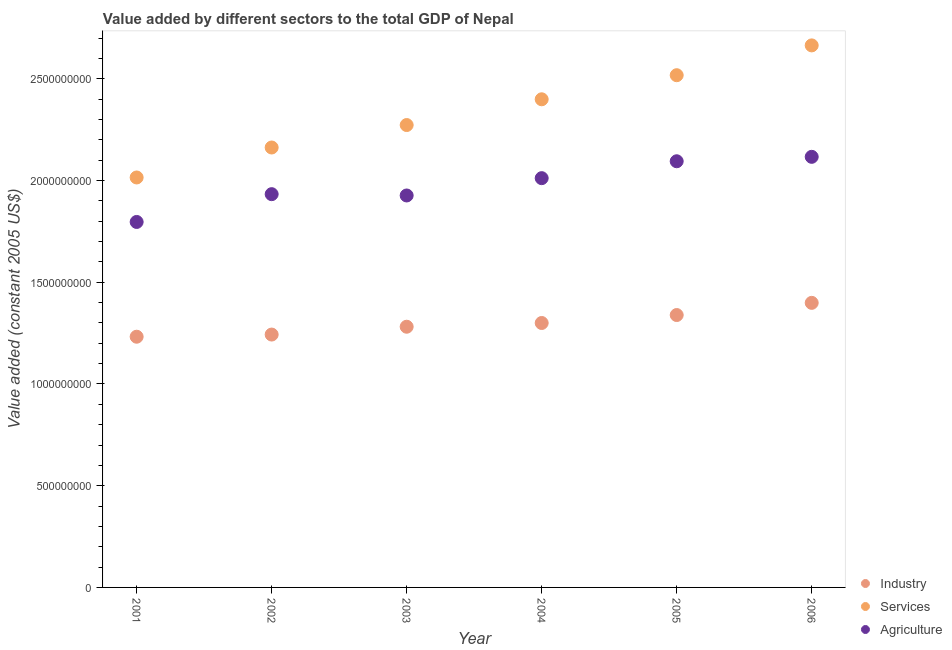What is the value added by agricultural sector in 2005?
Your answer should be compact. 2.09e+09. Across all years, what is the maximum value added by services?
Provide a succinct answer. 2.66e+09. Across all years, what is the minimum value added by industrial sector?
Your response must be concise. 1.23e+09. In which year was the value added by agricultural sector maximum?
Ensure brevity in your answer.  2006. In which year was the value added by services minimum?
Your answer should be very brief. 2001. What is the total value added by industrial sector in the graph?
Give a very brief answer. 7.79e+09. What is the difference between the value added by industrial sector in 2003 and that in 2005?
Make the answer very short. -5.75e+07. What is the difference between the value added by services in 2004 and the value added by agricultural sector in 2005?
Make the answer very short. 3.05e+08. What is the average value added by industrial sector per year?
Your answer should be very brief. 1.30e+09. In the year 2006, what is the difference between the value added by industrial sector and value added by agricultural sector?
Offer a very short reply. -7.18e+08. What is the ratio of the value added by services in 2001 to that in 2005?
Ensure brevity in your answer.  0.8. What is the difference between the highest and the second highest value added by industrial sector?
Ensure brevity in your answer.  5.99e+07. What is the difference between the highest and the lowest value added by industrial sector?
Provide a succinct answer. 1.66e+08. In how many years, is the value added by industrial sector greater than the average value added by industrial sector taken over all years?
Provide a succinct answer. 3. Does the value added by agricultural sector monotonically increase over the years?
Provide a short and direct response. No. Are the values on the major ticks of Y-axis written in scientific E-notation?
Provide a succinct answer. No. Does the graph contain grids?
Your answer should be very brief. No. How are the legend labels stacked?
Offer a very short reply. Vertical. What is the title of the graph?
Ensure brevity in your answer.  Value added by different sectors to the total GDP of Nepal. What is the label or title of the Y-axis?
Offer a very short reply. Value added (constant 2005 US$). What is the Value added (constant 2005 US$) of Industry in 2001?
Provide a succinct answer. 1.23e+09. What is the Value added (constant 2005 US$) in Services in 2001?
Give a very brief answer. 2.01e+09. What is the Value added (constant 2005 US$) of Agriculture in 2001?
Ensure brevity in your answer.  1.80e+09. What is the Value added (constant 2005 US$) of Industry in 2002?
Give a very brief answer. 1.24e+09. What is the Value added (constant 2005 US$) in Services in 2002?
Offer a very short reply. 2.16e+09. What is the Value added (constant 2005 US$) in Agriculture in 2002?
Your answer should be compact. 1.93e+09. What is the Value added (constant 2005 US$) of Industry in 2003?
Keep it short and to the point. 1.28e+09. What is the Value added (constant 2005 US$) in Services in 2003?
Make the answer very short. 2.27e+09. What is the Value added (constant 2005 US$) of Agriculture in 2003?
Provide a succinct answer. 1.93e+09. What is the Value added (constant 2005 US$) of Industry in 2004?
Give a very brief answer. 1.30e+09. What is the Value added (constant 2005 US$) of Services in 2004?
Offer a very short reply. 2.40e+09. What is the Value added (constant 2005 US$) of Agriculture in 2004?
Your answer should be compact. 2.01e+09. What is the Value added (constant 2005 US$) in Industry in 2005?
Ensure brevity in your answer.  1.34e+09. What is the Value added (constant 2005 US$) of Services in 2005?
Your answer should be compact. 2.52e+09. What is the Value added (constant 2005 US$) in Agriculture in 2005?
Give a very brief answer. 2.09e+09. What is the Value added (constant 2005 US$) of Industry in 2006?
Make the answer very short. 1.40e+09. What is the Value added (constant 2005 US$) in Services in 2006?
Provide a short and direct response. 2.66e+09. What is the Value added (constant 2005 US$) in Agriculture in 2006?
Your answer should be compact. 2.12e+09. Across all years, what is the maximum Value added (constant 2005 US$) of Industry?
Ensure brevity in your answer.  1.40e+09. Across all years, what is the maximum Value added (constant 2005 US$) of Services?
Provide a succinct answer. 2.66e+09. Across all years, what is the maximum Value added (constant 2005 US$) in Agriculture?
Offer a very short reply. 2.12e+09. Across all years, what is the minimum Value added (constant 2005 US$) of Industry?
Give a very brief answer. 1.23e+09. Across all years, what is the minimum Value added (constant 2005 US$) in Services?
Your answer should be very brief. 2.01e+09. Across all years, what is the minimum Value added (constant 2005 US$) in Agriculture?
Your response must be concise. 1.80e+09. What is the total Value added (constant 2005 US$) of Industry in the graph?
Your answer should be very brief. 7.79e+09. What is the total Value added (constant 2005 US$) of Services in the graph?
Keep it short and to the point. 1.40e+1. What is the total Value added (constant 2005 US$) of Agriculture in the graph?
Give a very brief answer. 1.19e+1. What is the difference between the Value added (constant 2005 US$) in Industry in 2001 and that in 2002?
Ensure brevity in your answer.  -1.07e+07. What is the difference between the Value added (constant 2005 US$) of Services in 2001 and that in 2002?
Ensure brevity in your answer.  -1.47e+08. What is the difference between the Value added (constant 2005 US$) of Agriculture in 2001 and that in 2002?
Ensure brevity in your answer.  -1.37e+08. What is the difference between the Value added (constant 2005 US$) in Industry in 2001 and that in 2003?
Provide a short and direct response. -4.91e+07. What is the difference between the Value added (constant 2005 US$) of Services in 2001 and that in 2003?
Ensure brevity in your answer.  -2.58e+08. What is the difference between the Value added (constant 2005 US$) in Agriculture in 2001 and that in 2003?
Your response must be concise. -1.30e+08. What is the difference between the Value added (constant 2005 US$) in Industry in 2001 and that in 2004?
Make the answer very short. -6.75e+07. What is the difference between the Value added (constant 2005 US$) of Services in 2001 and that in 2004?
Ensure brevity in your answer.  -3.84e+08. What is the difference between the Value added (constant 2005 US$) in Agriculture in 2001 and that in 2004?
Offer a very short reply. -2.15e+08. What is the difference between the Value added (constant 2005 US$) in Industry in 2001 and that in 2005?
Provide a short and direct response. -1.07e+08. What is the difference between the Value added (constant 2005 US$) of Services in 2001 and that in 2005?
Provide a succinct answer. -5.03e+08. What is the difference between the Value added (constant 2005 US$) of Agriculture in 2001 and that in 2005?
Offer a very short reply. -2.98e+08. What is the difference between the Value added (constant 2005 US$) of Industry in 2001 and that in 2006?
Give a very brief answer. -1.66e+08. What is the difference between the Value added (constant 2005 US$) of Services in 2001 and that in 2006?
Your answer should be compact. -6.49e+08. What is the difference between the Value added (constant 2005 US$) in Agriculture in 2001 and that in 2006?
Offer a terse response. -3.20e+08. What is the difference between the Value added (constant 2005 US$) in Industry in 2002 and that in 2003?
Give a very brief answer. -3.84e+07. What is the difference between the Value added (constant 2005 US$) in Services in 2002 and that in 2003?
Keep it short and to the point. -1.10e+08. What is the difference between the Value added (constant 2005 US$) of Agriculture in 2002 and that in 2003?
Offer a very short reply. 6.44e+06. What is the difference between the Value added (constant 2005 US$) of Industry in 2002 and that in 2004?
Your response must be concise. -5.68e+07. What is the difference between the Value added (constant 2005 US$) of Services in 2002 and that in 2004?
Give a very brief answer. -2.37e+08. What is the difference between the Value added (constant 2005 US$) of Agriculture in 2002 and that in 2004?
Your response must be concise. -7.87e+07. What is the difference between the Value added (constant 2005 US$) of Industry in 2002 and that in 2005?
Ensure brevity in your answer.  -9.59e+07. What is the difference between the Value added (constant 2005 US$) of Services in 2002 and that in 2005?
Your answer should be very brief. -3.55e+08. What is the difference between the Value added (constant 2005 US$) in Agriculture in 2002 and that in 2005?
Offer a terse response. -1.62e+08. What is the difference between the Value added (constant 2005 US$) of Industry in 2002 and that in 2006?
Give a very brief answer. -1.56e+08. What is the difference between the Value added (constant 2005 US$) of Services in 2002 and that in 2006?
Ensure brevity in your answer.  -5.02e+08. What is the difference between the Value added (constant 2005 US$) in Agriculture in 2002 and that in 2006?
Keep it short and to the point. -1.84e+08. What is the difference between the Value added (constant 2005 US$) of Industry in 2003 and that in 2004?
Give a very brief answer. -1.84e+07. What is the difference between the Value added (constant 2005 US$) of Services in 2003 and that in 2004?
Your response must be concise. -1.27e+08. What is the difference between the Value added (constant 2005 US$) of Agriculture in 2003 and that in 2004?
Keep it short and to the point. -8.51e+07. What is the difference between the Value added (constant 2005 US$) in Industry in 2003 and that in 2005?
Provide a succinct answer. -5.75e+07. What is the difference between the Value added (constant 2005 US$) of Services in 2003 and that in 2005?
Make the answer very short. -2.45e+08. What is the difference between the Value added (constant 2005 US$) in Agriculture in 2003 and that in 2005?
Provide a short and direct response. -1.68e+08. What is the difference between the Value added (constant 2005 US$) of Industry in 2003 and that in 2006?
Provide a short and direct response. -1.17e+08. What is the difference between the Value added (constant 2005 US$) in Services in 2003 and that in 2006?
Provide a short and direct response. -3.91e+08. What is the difference between the Value added (constant 2005 US$) of Agriculture in 2003 and that in 2006?
Offer a very short reply. -1.90e+08. What is the difference between the Value added (constant 2005 US$) of Industry in 2004 and that in 2005?
Your answer should be compact. -3.91e+07. What is the difference between the Value added (constant 2005 US$) of Services in 2004 and that in 2005?
Make the answer very short. -1.18e+08. What is the difference between the Value added (constant 2005 US$) in Agriculture in 2004 and that in 2005?
Your answer should be compact. -8.31e+07. What is the difference between the Value added (constant 2005 US$) in Industry in 2004 and that in 2006?
Your answer should be compact. -9.90e+07. What is the difference between the Value added (constant 2005 US$) in Services in 2004 and that in 2006?
Ensure brevity in your answer.  -2.65e+08. What is the difference between the Value added (constant 2005 US$) of Agriculture in 2004 and that in 2006?
Keep it short and to the point. -1.05e+08. What is the difference between the Value added (constant 2005 US$) of Industry in 2005 and that in 2006?
Make the answer very short. -5.99e+07. What is the difference between the Value added (constant 2005 US$) of Services in 2005 and that in 2006?
Your answer should be very brief. -1.47e+08. What is the difference between the Value added (constant 2005 US$) of Agriculture in 2005 and that in 2006?
Keep it short and to the point. -2.18e+07. What is the difference between the Value added (constant 2005 US$) in Industry in 2001 and the Value added (constant 2005 US$) in Services in 2002?
Give a very brief answer. -9.30e+08. What is the difference between the Value added (constant 2005 US$) of Industry in 2001 and the Value added (constant 2005 US$) of Agriculture in 2002?
Your response must be concise. -7.01e+08. What is the difference between the Value added (constant 2005 US$) of Services in 2001 and the Value added (constant 2005 US$) of Agriculture in 2002?
Give a very brief answer. 8.20e+07. What is the difference between the Value added (constant 2005 US$) of Industry in 2001 and the Value added (constant 2005 US$) of Services in 2003?
Give a very brief answer. -1.04e+09. What is the difference between the Value added (constant 2005 US$) of Industry in 2001 and the Value added (constant 2005 US$) of Agriculture in 2003?
Ensure brevity in your answer.  -6.94e+08. What is the difference between the Value added (constant 2005 US$) of Services in 2001 and the Value added (constant 2005 US$) of Agriculture in 2003?
Your response must be concise. 8.85e+07. What is the difference between the Value added (constant 2005 US$) of Industry in 2001 and the Value added (constant 2005 US$) of Services in 2004?
Offer a very short reply. -1.17e+09. What is the difference between the Value added (constant 2005 US$) in Industry in 2001 and the Value added (constant 2005 US$) in Agriculture in 2004?
Make the answer very short. -7.79e+08. What is the difference between the Value added (constant 2005 US$) of Services in 2001 and the Value added (constant 2005 US$) of Agriculture in 2004?
Keep it short and to the point. 3.36e+06. What is the difference between the Value added (constant 2005 US$) in Industry in 2001 and the Value added (constant 2005 US$) in Services in 2005?
Offer a terse response. -1.29e+09. What is the difference between the Value added (constant 2005 US$) in Industry in 2001 and the Value added (constant 2005 US$) in Agriculture in 2005?
Provide a short and direct response. -8.62e+08. What is the difference between the Value added (constant 2005 US$) of Services in 2001 and the Value added (constant 2005 US$) of Agriculture in 2005?
Offer a very short reply. -7.97e+07. What is the difference between the Value added (constant 2005 US$) in Industry in 2001 and the Value added (constant 2005 US$) in Services in 2006?
Make the answer very short. -1.43e+09. What is the difference between the Value added (constant 2005 US$) in Industry in 2001 and the Value added (constant 2005 US$) in Agriculture in 2006?
Your response must be concise. -8.84e+08. What is the difference between the Value added (constant 2005 US$) of Services in 2001 and the Value added (constant 2005 US$) of Agriculture in 2006?
Your response must be concise. -1.01e+08. What is the difference between the Value added (constant 2005 US$) in Industry in 2002 and the Value added (constant 2005 US$) in Services in 2003?
Keep it short and to the point. -1.03e+09. What is the difference between the Value added (constant 2005 US$) in Industry in 2002 and the Value added (constant 2005 US$) in Agriculture in 2003?
Provide a succinct answer. -6.84e+08. What is the difference between the Value added (constant 2005 US$) of Services in 2002 and the Value added (constant 2005 US$) of Agriculture in 2003?
Ensure brevity in your answer.  2.36e+08. What is the difference between the Value added (constant 2005 US$) of Industry in 2002 and the Value added (constant 2005 US$) of Services in 2004?
Ensure brevity in your answer.  -1.16e+09. What is the difference between the Value added (constant 2005 US$) of Industry in 2002 and the Value added (constant 2005 US$) of Agriculture in 2004?
Keep it short and to the point. -7.69e+08. What is the difference between the Value added (constant 2005 US$) in Services in 2002 and the Value added (constant 2005 US$) in Agriculture in 2004?
Provide a succinct answer. 1.51e+08. What is the difference between the Value added (constant 2005 US$) in Industry in 2002 and the Value added (constant 2005 US$) in Services in 2005?
Make the answer very short. -1.27e+09. What is the difference between the Value added (constant 2005 US$) of Industry in 2002 and the Value added (constant 2005 US$) of Agriculture in 2005?
Offer a very short reply. -8.52e+08. What is the difference between the Value added (constant 2005 US$) in Services in 2002 and the Value added (constant 2005 US$) in Agriculture in 2005?
Offer a very short reply. 6.76e+07. What is the difference between the Value added (constant 2005 US$) in Industry in 2002 and the Value added (constant 2005 US$) in Services in 2006?
Provide a short and direct response. -1.42e+09. What is the difference between the Value added (constant 2005 US$) of Industry in 2002 and the Value added (constant 2005 US$) of Agriculture in 2006?
Make the answer very short. -8.74e+08. What is the difference between the Value added (constant 2005 US$) of Services in 2002 and the Value added (constant 2005 US$) of Agriculture in 2006?
Keep it short and to the point. 4.58e+07. What is the difference between the Value added (constant 2005 US$) in Industry in 2003 and the Value added (constant 2005 US$) in Services in 2004?
Your response must be concise. -1.12e+09. What is the difference between the Value added (constant 2005 US$) of Industry in 2003 and the Value added (constant 2005 US$) of Agriculture in 2004?
Provide a short and direct response. -7.30e+08. What is the difference between the Value added (constant 2005 US$) of Services in 2003 and the Value added (constant 2005 US$) of Agriculture in 2004?
Offer a terse response. 2.61e+08. What is the difference between the Value added (constant 2005 US$) of Industry in 2003 and the Value added (constant 2005 US$) of Services in 2005?
Offer a very short reply. -1.24e+09. What is the difference between the Value added (constant 2005 US$) in Industry in 2003 and the Value added (constant 2005 US$) in Agriculture in 2005?
Offer a very short reply. -8.13e+08. What is the difference between the Value added (constant 2005 US$) of Services in 2003 and the Value added (constant 2005 US$) of Agriculture in 2005?
Your answer should be very brief. 1.78e+08. What is the difference between the Value added (constant 2005 US$) of Industry in 2003 and the Value added (constant 2005 US$) of Services in 2006?
Offer a very short reply. -1.38e+09. What is the difference between the Value added (constant 2005 US$) of Industry in 2003 and the Value added (constant 2005 US$) of Agriculture in 2006?
Provide a short and direct response. -8.35e+08. What is the difference between the Value added (constant 2005 US$) of Services in 2003 and the Value added (constant 2005 US$) of Agriculture in 2006?
Your answer should be very brief. 1.56e+08. What is the difference between the Value added (constant 2005 US$) of Industry in 2004 and the Value added (constant 2005 US$) of Services in 2005?
Offer a terse response. -1.22e+09. What is the difference between the Value added (constant 2005 US$) in Industry in 2004 and the Value added (constant 2005 US$) in Agriculture in 2005?
Ensure brevity in your answer.  -7.95e+08. What is the difference between the Value added (constant 2005 US$) of Services in 2004 and the Value added (constant 2005 US$) of Agriculture in 2005?
Keep it short and to the point. 3.05e+08. What is the difference between the Value added (constant 2005 US$) of Industry in 2004 and the Value added (constant 2005 US$) of Services in 2006?
Make the answer very short. -1.36e+09. What is the difference between the Value added (constant 2005 US$) of Industry in 2004 and the Value added (constant 2005 US$) of Agriculture in 2006?
Keep it short and to the point. -8.17e+08. What is the difference between the Value added (constant 2005 US$) of Services in 2004 and the Value added (constant 2005 US$) of Agriculture in 2006?
Your answer should be compact. 2.83e+08. What is the difference between the Value added (constant 2005 US$) in Industry in 2005 and the Value added (constant 2005 US$) in Services in 2006?
Provide a short and direct response. -1.33e+09. What is the difference between the Value added (constant 2005 US$) in Industry in 2005 and the Value added (constant 2005 US$) in Agriculture in 2006?
Your response must be concise. -7.78e+08. What is the difference between the Value added (constant 2005 US$) in Services in 2005 and the Value added (constant 2005 US$) in Agriculture in 2006?
Your answer should be very brief. 4.01e+08. What is the average Value added (constant 2005 US$) in Industry per year?
Offer a very short reply. 1.30e+09. What is the average Value added (constant 2005 US$) of Services per year?
Your answer should be very brief. 2.34e+09. What is the average Value added (constant 2005 US$) of Agriculture per year?
Keep it short and to the point. 1.98e+09. In the year 2001, what is the difference between the Value added (constant 2005 US$) in Industry and Value added (constant 2005 US$) in Services?
Your answer should be very brief. -7.83e+08. In the year 2001, what is the difference between the Value added (constant 2005 US$) of Industry and Value added (constant 2005 US$) of Agriculture?
Provide a succinct answer. -5.64e+08. In the year 2001, what is the difference between the Value added (constant 2005 US$) in Services and Value added (constant 2005 US$) in Agriculture?
Make the answer very short. 2.19e+08. In the year 2002, what is the difference between the Value added (constant 2005 US$) of Industry and Value added (constant 2005 US$) of Services?
Your answer should be compact. -9.19e+08. In the year 2002, what is the difference between the Value added (constant 2005 US$) in Industry and Value added (constant 2005 US$) in Agriculture?
Your answer should be very brief. -6.90e+08. In the year 2002, what is the difference between the Value added (constant 2005 US$) of Services and Value added (constant 2005 US$) of Agriculture?
Provide a short and direct response. 2.29e+08. In the year 2003, what is the difference between the Value added (constant 2005 US$) in Industry and Value added (constant 2005 US$) in Services?
Make the answer very short. -9.91e+08. In the year 2003, what is the difference between the Value added (constant 2005 US$) in Industry and Value added (constant 2005 US$) in Agriculture?
Offer a very short reply. -6.45e+08. In the year 2003, what is the difference between the Value added (constant 2005 US$) of Services and Value added (constant 2005 US$) of Agriculture?
Provide a succinct answer. 3.46e+08. In the year 2004, what is the difference between the Value added (constant 2005 US$) of Industry and Value added (constant 2005 US$) of Services?
Your response must be concise. -1.10e+09. In the year 2004, what is the difference between the Value added (constant 2005 US$) in Industry and Value added (constant 2005 US$) in Agriculture?
Your answer should be very brief. -7.12e+08. In the year 2004, what is the difference between the Value added (constant 2005 US$) of Services and Value added (constant 2005 US$) of Agriculture?
Provide a short and direct response. 3.88e+08. In the year 2005, what is the difference between the Value added (constant 2005 US$) in Industry and Value added (constant 2005 US$) in Services?
Your response must be concise. -1.18e+09. In the year 2005, what is the difference between the Value added (constant 2005 US$) in Industry and Value added (constant 2005 US$) in Agriculture?
Give a very brief answer. -7.56e+08. In the year 2005, what is the difference between the Value added (constant 2005 US$) in Services and Value added (constant 2005 US$) in Agriculture?
Your answer should be very brief. 4.23e+08. In the year 2006, what is the difference between the Value added (constant 2005 US$) in Industry and Value added (constant 2005 US$) in Services?
Offer a very short reply. -1.27e+09. In the year 2006, what is the difference between the Value added (constant 2005 US$) of Industry and Value added (constant 2005 US$) of Agriculture?
Your answer should be very brief. -7.18e+08. In the year 2006, what is the difference between the Value added (constant 2005 US$) of Services and Value added (constant 2005 US$) of Agriculture?
Make the answer very short. 5.48e+08. What is the ratio of the Value added (constant 2005 US$) in Services in 2001 to that in 2002?
Make the answer very short. 0.93. What is the ratio of the Value added (constant 2005 US$) of Agriculture in 2001 to that in 2002?
Give a very brief answer. 0.93. What is the ratio of the Value added (constant 2005 US$) of Industry in 2001 to that in 2003?
Your answer should be compact. 0.96. What is the ratio of the Value added (constant 2005 US$) of Services in 2001 to that in 2003?
Give a very brief answer. 0.89. What is the ratio of the Value added (constant 2005 US$) in Agriculture in 2001 to that in 2003?
Keep it short and to the point. 0.93. What is the ratio of the Value added (constant 2005 US$) in Industry in 2001 to that in 2004?
Ensure brevity in your answer.  0.95. What is the ratio of the Value added (constant 2005 US$) of Services in 2001 to that in 2004?
Your answer should be compact. 0.84. What is the ratio of the Value added (constant 2005 US$) in Agriculture in 2001 to that in 2004?
Your answer should be compact. 0.89. What is the ratio of the Value added (constant 2005 US$) of Industry in 2001 to that in 2005?
Your answer should be compact. 0.92. What is the ratio of the Value added (constant 2005 US$) in Services in 2001 to that in 2005?
Make the answer very short. 0.8. What is the ratio of the Value added (constant 2005 US$) in Agriculture in 2001 to that in 2005?
Keep it short and to the point. 0.86. What is the ratio of the Value added (constant 2005 US$) of Industry in 2001 to that in 2006?
Offer a terse response. 0.88. What is the ratio of the Value added (constant 2005 US$) in Services in 2001 to that in 2006?
Keep it short and to the point. 0.76. What is the ratio of the Value added (constant 2005 US$) in Agriculture in 2001 to that in 2006?
Your response must be concise. 0.85. What is the ratio of the Value added (constant 2005 US$) in Services in 2002 to that in 2003?
Give a very brief answer. 0.95. What is the ratio of the Value added (constant 2005 US$) in Industry in 2002 to that in 2004?
Make the answer very short. 0.96. What is the ratio of the Value added (constant 2005 US$) of Services in 2002 to that in 2004?
Your answer should be very brief. 0.9. What is the ratio of the Value added (constant 2005 US$) of Agriculture in 2002 to that in 2004?
Keep it short and to the point. 0.96. What is the ratio of the Value added (constant 2005 US$) of Industry in 2002 to that in 2005?
Keep it short and to the point. 0.93. What is the ratio of the Value added (constant 2005 US$) of Services in 2002 to that in 2005?
Offer a terse response. 0.86. What is the ratio of the Value added (constant 2005 US$) of Agriculture in 2002 to that in 2005?
Ensure brevity in your answer.  0.92. What is the ratio of the Value added (constant 2005 US$) in Industry in 2002 to that in 2006?
Your answer should be very brief. 0.89. What is the ratio of the Value added (constant 2005 US$) in Services in 2002 to that in 2006?
Give a very brief answer. 0.81. What is the ratio of the Value added (constant 2005 US$) in Agriculture in 2002 to that in 2006?
Provide a succinct answer. 0.91. What is the ratio of the Value added (constant 2005 US$) in Industry in 2003 to that in 2004?
Your answer should be compact. 0.99. What is the ratio of the Value added (constant 2005 US$) of Services in 2003 to that in 2004?
Your answer should be very brief. 0.95. What is the ratio of the Value added (constant 2005 US$) in Agriculture in 2003 to that in 2004?
Your answer should be compact. 0.96. What is the ratio of the Value added (constant 2005 US$) of Industry in 2003 to that in 2005?
Give a very brief answer. 0.96. What is the ratio of the Value added (constant 2005 US$) of Services in 2003 to that in 2005?
Your answer should be very brief. 0.9. What is the ratio of the Value added (constant 2005 US$) in Agriculture in 2003 to that in 2005?
Offer a terse response. 0.92. What is the ratio of the Value added (constant 2005 US$) in Industry in 2003 to that in 2006?
Provide a succinct answer. 0.92. What is the ratio of the Value added (constant 2005 US$) in Services in 2003 to that in 2006?
Your answer should be very brief. 0.85. What is the ratio of the Value added (constant 2005 US$) of Agriculture in 2003 to that in 2006?
Your response must be concise. 0.91. What is the ratio of the Value added (constant 2005 US$) in Industry in 2004 to that in 2005?
Keep it short and to the point. 0.97. What is the ratio of the Value added (constant 2005 US$) of Services in 2004 to that in 2005?
Provide a succinct answer. 0.95. What is the ratio of the Value added (constant 2005 US$) of Agriculture in 2004 to that in 2005?
Keep it short and to the point. 0.96. What is the ratio of the Value added (constant 2005 US$) of Industry in 2004 to that in 2006?
Ensure brevity in your answer.  0.93. What is the ratio of the Value added (constant 2005 US$) in Services in 2004 to that in 2006?
Give a very brief answer. 0.9. What is the ratio of the Value added (constant 2005 US$) in Agriculture in 2004 to that in 2006?
Keep it short and to the point. 0.95. What is the ratio of the Value added (constant 2005 US$) of Industry in 2005 to that in 2006?
Provide a succinct answer. 0.96. What is the ratio of the Value added (constant 2005 US$) of Services in 2005 to that in 2006?
Offer a terse response. 0.94. What is the difference between the highest and the second highest Value added (constant 2005 US$) of Industry?
Your answer should be compact. 5.99e+07. What is the difference between the highest and the second highest Value added (constant 2005 US$) of Services?
Give a very brief answer. 1.47e+08. What is the difference between the highest and the second highest Value added (constant 2005 US$) of Agriculture?
Provide a succinct answer. 2.18e+07. What is the difference between the highest and the lowest Value added (constant 2005 US$) of Industry?
Offer a very short reply. 1.66e+08. What is the difference between the highest and the lowest Value added (constant 2005 US$) of Services?
Your answer should be very brief. 6.49e+08. What is the difference between the highest and the lowest Value added (constant 2005 US$) in Agriculture?
Provide a short and direct response. 3.20e+08. 